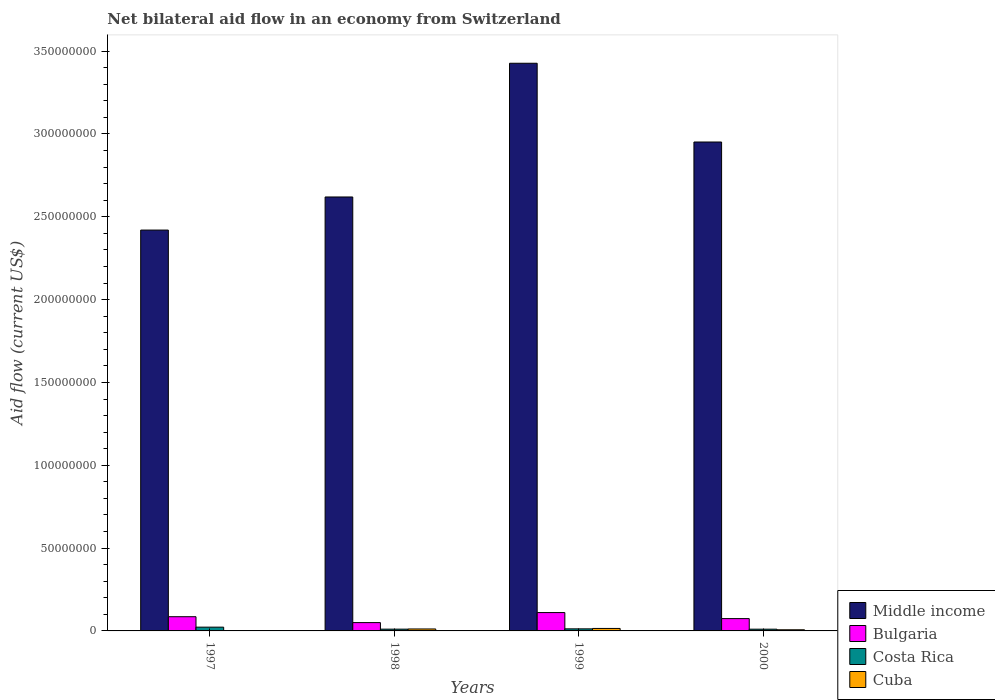Are the number of bars on each tick of the X-axis equal?
Give a very brief answer. Yes. How many bars are there on the 3rd tick from the right?
Offer a very short reply. 4. What is the label of the 1st group of bars from the left?
Your answer should be compact. 1997. What is the net bilateral aid flow in Cuba in 2000?
Keep it short and to the point. 6.90e+05. Across all years, what is the maximum net bilateral aid flow in Bulgaria?
Give a very brief answer. 1.11e+07. Across all years, what is the minimum net bilateral aid flow in Middle income?
Give a very brief answer. 2.42e+08. In which year was the net bilateral aid flow in Middle income maximum?
Offer a very short reply. 1999. What is the total net bilateral aid flow in Middle income in the graph?
Your answer should be compact. 1.14e+09. What is the difference between the net bilateral aid flow in Middle income in 1997 and that in 2000?
Provide a succinct answer. -5.32e+07. What is the difference between the net bilateral aid flow in Cuba in 1997 and the net bilateral aid flow in Bulgaria in 1999?
Your answer should be very brief. -1.09e+07. What is the average net bilateral aid flow in Bulgaria per year?
Provide a succinct answer. 8.03e+06. In the year 2000, what is the difference between the net bilateral aid flow in Costa Rica and net bilateral aid flow in Bulgaria?
Keep it short and to the point. -6.39e+06. What is the ratio of the net bilateral aid flow in Bulgaria in 1998 to that in 1999?
Your answer should be compact. 0.45. Is the net bilateral aid flow in Cuba in 1998 less than that in 2000?
Make the answer very short. No. What is the difference between the highest and the lowest net bilateral aid flow in Bulgaria?
Provide a short and direct response. 6.06e+06. In how many years, is the net bilateral aid flow in Middle income greater than the average net bilateral aid flow in Middle income taken over all years?
Your response must be concise. 2. What does the 4th bar from the right in 1999 represents?
Give a very brief answer. Middle income. Are all the bars in the graph horizontal?
Make the answer very short. No. How many years are there in the graph?
Give a very brief answer. 4. Does the graph contain any zero values?
Ensure brevity in your answer.  No. Does the graph contain grids?
Provide a short and direct response. No. Where does the legend appear in the graph?
Your answer should be compact. Bottom right. What is the title of the graph?
Provide a succinct answer. Net bilateral aid flow in an economy from Switzerland. What is the label or title of the X-axis?
Your answer should be very brief. Years. What is the Aid flow (current US$) of Middle income in 1997?
Ensure brevity in your answer.  2.42e+08. What is the Aid flow (current US$) in Bulgaria in 1997?
Keep it short and to the point. 8.58e+06. What is the Aid flow (current US$) in Costa Rica in 1997?
Ensure brevity in your answer.  2.28e+06. What is the Aid flow (current US$) of Middle income in 1998?
Provide a short and direct response. 2.62e+08. What is the Aid flow (current US$) of Bulgaria in 1998?
Provide a short and direct response. 5.02e+06. What is the Aid flow (current US$) of Costa Rica in 1998?
Your answer should be very brief. 1.07e+06. What is the Aid flow (current US$) of Cuba in 1998?
Offer a very short reply. 1.18e+06. What is the Aid flow (current US$) of Middle income in 1999?
Offer a very short reply. 3.43e+08. What is the Aid flow (current US$) in Bulgaria in 1999?
Offer a very short reply. 1.11e+07. What is the Aid flow (current US$) in Costa Rica in 1999?
Your answer should be very brief. 1.25e+06. What is the Aid flow (current US$) in Cuba in 1999?
Make the answer very short. 1.49e+06. What is the Aid flow (current US$) of Middle income in 2000?
Offer a terse response. 2.95e+08. What is the Aid flow (current US$) in Bulgaria in 2000?
Your answer should be compact. 7.44e+06. What is the Aid flow (current US$) in Costa Rica in 2000?
Your answer should be very brief. 1.05e+06. What is the Aid flow (current US$) in Cuba in 2000?
Offer a very short reply. 6.90e+05. Across all years, what is the maximum Aid flow (current US$) in Middle income?
Offer a terse response. 3.43e+08. Across all years, what is the maximum Aid flow (current US$) in Bulgaria?
Offer a very short reply. 1.11e+07. Across all years, what is the maximum Aid flow (current US$) of Costa Rica?
Keep it short and to the point. 2.28e+06. Across all years, what is the maximum Aid flow (current US$) of Cuba?
Offer a terse response. 1.49e+06. Across all years, what is the minimum Aid flow (current US$) in Middle income?
Provide a short and direct response. 2.42e+08. Across all years, what is the minimum Aid flow (current US$) in Bulgaria?
Provide a succinct answer. 5.02e+06. Across all years, what is the minimum Aid flow (current US$) of Costa Rica?
Offer a very short reply. 1.05e+06. What is the total Aid flow (current US$) of Middle income in the graph?
Provide a short and direct response. 1.14e+09. What is the total Aid flow (current US$) of Bulgaria in the graph?
Provide a succinct answer. 3.21e+07. What is the total Aid flow (current US$) in Costa Rica in the graph?
Your answer should be compact. 5.65e+06. What is the total Aid flow (current US$) of Cuba in the graph?
Ensure brevity in your answer.  3.52e+06. What is the difference between the Aid flow (current US$) in Middle income in 1997 and that in 1998?
Your answer should be compact. -2.00e+07. What is the difference between the Aid flow (current US$) of Bulgaria in 1997 and that in 1998?
Your answer should be compact. 3.56e+06. What is the difference between the Aid flow (current US$) of Costa Rica in 1997 and that in 1998?
Make the answer very short. 1.21e+06. What is the difference between the Aid flow (current US$) in Cuba in 1997 and that in 1998?
Provide a succinct answer. -1.02e+06. What is the difference between the Aid flow (current US$) in Middle income in 1997 and that in 1999?
Your response must be concise. -1.01e+08. What is the difference between the Aid flow (current US$) of Bulgaria in 1997 and that in 1999?
Provide a succinct answer. -2.50e+06. What is the difference between the Aid flow (current US$) in Costa Rica in 1997 and that in 1999?
Ensure brevity in your answer.  1.03e+06. What is the difference between the Aid flow (current US$) in Cuba in 1997 and that in 1999?
Keep it short and to the point. -1.33e+06. What is the difference between the Aid flow (current US$) of Middle income in 1997 and that in 2000?
Make the answer very short. -5.32e+07. What is the difference between the Aid flow (current US$) of Bulgaria in 1997 and that in 2000?
Make the answer very short. 1.14e+06. What is the difference between the Aid flow (current US$) of Costa Rica in 1997 and that in 2000?
Your answer should be compact. 1.23e+06. What is the difference between the Aid flow (current US$) in Cuba in 1997 and that in 2000?
Keep it short and to the point. -5.30e+05. What is the difference between the Aid flow (current US$) of Middle income in 1998 and that in 1999?
Ensure brevity in your answer.  -8.07e+07. What is the difference between the Aid flow (current US$) of Bulgaria in 1998 and that in 1999?
Offer a terse response. -6.06e+06. What is the difference between the Aid flow (current US$) in Costa Rica in 1998 and that in 1999?
Give a very brief answer. -1.80e+05. What is the difference between the Aid flow (current US$) in Cuba in 1998 and that in 1999?
Offer a very short reply. -3.10e+05. What is the difference between the Aid flow (current US$) in Middle income in 1998 and that in 2000?
Ensure brevity in your answer.  -3.32e+07. What is the difference between the Aid flow (current US$) of Bulgaria in 1998 and that in 2000?
Provide a succinct answer. -2.42e+06. What is the difference between the Aid flow (current US$) in Costa Rica in 1998 and that in 2000?
Offer a terse response. 2.00e+04. What is the difference between the Aid flow (current US$) of Cuba in 1998 and that in 2000?
Your response must be concise. 4.90e+05. What is the difference between the Aid flow (current US$) of Middle income in 1999 and that in 2000?
Offer a terse response. 4.75e+07. What is the difference between the Aid flow (current US$) of Bulgaria in 1999 and that in 2000?
Your answer should be compact. 3.64e+06. What is the difference between the Aid flow (current US$) of Cuba in 1999 and that in 2000?
Ensure brevity in your answer.  8.00e+05. What is the difference between the Aid flow (current US$) of Middle income in 1997 and the Aid flow (current US$) of Bulgaria in 1998?
Make the answer very short. 2.37e+08. What is the difference between the Aid flow (current US$) of Middle income in 1997 and the Aid flow (current US$) of Costa Rica in 1998?
Offer a very short reply. 2.41e+08. What is the difference between the Aid flow (current US$) of Middle income in 1997 and the Aid flow (current US$) of Cuba in 1998?
Offer a very short reply. 2.41e+08. What is the difference between the Aid flow (current US$) in Bulgaria in 1997 and the Aid flow (current US$) in Costa Rica in 1998?
Keep it short and to the point. 7.51e+06. What is the difference between the Aid flow (current US$) in Bulgaria in 1997 and the Aid flow (current US$) in Cuba in 1998?
Offer a terse response. 7.40e+06. What is the difference between the Aid flow (current US$) in Costa Rica in 1997 and the Aid flow (current US$) in Cuba in 1998?
Give a very brief answer. 1.10e+06. What is the difference between the Aid flow (current US$) of Middle income in 1997 and the Aid flow (current US$) of Bulgaria in 1999?
Your answer should be compact. 2.31e+08. What is the difference between the Aid flow (current US$) of Middle income in 1997 and the Aid flow (current US$) of Costa Rica in 1999?
Your answer should be compact. 2.41e+08. What is the difference between the Aid flow (current US$) in Middle income in 1997 and the Aid flow (current US$) in Cuba in 1999?
Your response must be concise. 2.40e+08. What is the difference between the Aid flow (current US$) of Bulgaria in 1997 and the Aid flow (current US$) of Costa Rica in 1999?
Ensure brevity in your answer.  7.33e+06. What is the difference between the Aid flow (current US$) in Bulgaria in 1997 and the Aid flow (current US$) in Cuba in 1999?
Offer a terse response. 7.09e+06. What is the difference between the Aid flow (current US$) in Costa Rica in 1997 and the Aid flow (current US$) in Cuba in 1999?
Make the answer very short. 7.90e+05. What is the difference between the Aid flow (current US$) of Middle income in 1997 and the Aid flow (current US$) of Bulgaria in 2000?
Make the answer very short. 2.35e+08. What is the difference between the Aid flow (current US$) of Middle income in 1997 and the Aid flow (current US$) of Costa Rica in 2000?
Your answer should be very brief. 2.41e+08. What is the difference between the Aid flow (current US$) in Middle income in 1997 and the Aid flow (current US$) in Cuba in 2000?
Make the answer very short. 2.41e+08. What is the difference between the Aid flow (current US$) in Bulgaria in 1997 and the Aid flow (current US$) in Costa Rica in 2000?
Your response must be concise. 7.53e+06. What is the difference between the Aid flow (current US$) of Bulgaria in 1997 and the Aid flow (current US$) of Cuba in 2000?
Provide a succinct answer. 7.89e+06. What is the difference between the Aid flow (current US$) of Costa Rica in 1997 and the Aid flow (current US$) of Cuba in 2000?
Provide a short and direct response. 1.59e+06. What is the difference between the Aid flow (current US$) in Middle income in 1998 and the Aid flow (current US$) in Bulgaria in 1999?
Provide a succinct answer. 2.51e+08. What is the difference between the Aid flow (current US$) of Middle income in 1998 and the Aid flow (current US$) of Costa Rica in 1999?
Provide a succinct answer. 2.61e+08. What is the difference between the Aid flow (current US$) in Middle income in 1998 and the Aid flow (current US$) in Cuba in 1999?
Ensure brevity in your answer.  2.60e+08. What is the difference between the Aid flow (current US$) of Bulgaria in 1998 and the Aid flow (current US$) of Costa Rica in 1999?
Make the answer very short. 3.77e+06. What is the difference between the Aid flow (current US$) in Bulgaria in 1998 and the Aid flow (current US$) in Cuba in 1999?
Offer a terse response. 3.53e+06. What is the difference between the Aid flow (current US$) of Costa Rica in 1998 and the Aid flow (current US$) of Cuba in 1999?
Ensure brevity in your answer.  -4.20e+05. What is the difference between the Aid flow (current US$) of Middle income in 1998 and the Aid flow (current US$) of Bulgaria in 2000?
Give a very brief answer. 2.55e+08. What is the difference between the Aid flow (current US$) in Middle income in 1998 and the Aid flow (current US$) in Costa Rica in 2000?
Make the answer very short. 2.61e+08. What is the difference between the Aid flow (current US$) in Middle income in 1998 and the Aid flow (current US$) in Cuba in 2000?
Provide a short and direct response. 2.61e+08. What is the difference between the Aid flow (current US$) of Bulgaria in 1998 and the Aid flow (current US$) of Costa Rica in 2000?
Your response must be concise. 3.97e+06. What is the difference between the Aid flow (current US$) of Bulgaria in 1998 and the Aid flow (current US$) of Cuba in 2000?
Keep it short and to the point. 4.33e+06. What is the difference between the Aid flow (current US$) of Costa Rica in 1998 and the Aid flow (current US$) of Cuba in 2000?
Your answer should be very brief. 3.80e+05. What is the difference between the Aid flow (current US$) of Middle income in 1999 and the Aid flow (current US$) of Bulgaria in 2000?
Make the answer very short. 3.35e+08. What is the difference between the Aid flow (current US$) in Middle income in 1999 and the Aid flow (current US$) in Costa Rica in 2000?
Provide a short and direct response. 3.42e+08. What is the difference between the Aid flow (current US$) in Middle income in 1999 and the Aid flow (current US$) in Cuba in 2000?
Provide a short and direct response. 3.42e+08. What is the difference between the Aid flow (current US$) in Bulgaria in 1999 and the Aid flow (current US$) in Costa Rica in 2000?
Your answer should be compact. 1.00e+07. What is the difference between the Aid flow (current US$) of Bulgaria in 1999 and the Aid flow (current US$) of Cuba in 2000?
Provide a succinct answer. 1.04e+07. What is the difference between the Aid flow (current US$) in Costa Rica in 1999 and the Aid flow (current US$) in Cuba in 2000?
Offer a terse response. 5.60e+05. What is the average Aid flow (current US$) of Middle income per year?
Provide a succinct answer. 2.85e+08. What is the average Aid flow (current US$) of Bulgaria per year?
Offer a very short reply. 8.03e+06. What is the average Aid flow (current US$) of Costa Rica per year?
Provide a succinct answer. 1.41e+06. What is the average Aid flow (current US$) in Cuba per year?
Your answer should be compact. 8.80e+05. In the year 1997, what is the difference between the Aid flow (current US$) in Middle income and Aid flow (current US$) in Bulgaria?
Your answer should be compact. 2.33e+08. In the year 1997, what is the difference between the Aid flow (current US$) in Middle income and Aid flow (current US$) in Costa Rica?
Give a very brief answer. 2.40e+08. In the year 1997, what is the difference between the Aid flow (current US$) of Middle income and Aid flow (current US$) of Cuba?
Your answer should be very brief. 2.42e+08. In the year 1997, what is the difference between the Aid flow (current US$) in Bulgaria and Aid flow (current US$) in Costa Rica?
Offer a very short reply. 6.30e+06. In the year 1997, what is the difference between the Aid flow (current US$) of Bulgaria and Aid flow (current US$) of Cuba?
Your answer should be compact. 8.42e+06. In the year 1997, what is the difference between the Aid flow (current US$) in Costa Rica and Aid flow (current US$) in Cuba?
Your answer should be compact. 2.12e+06. In the year 1998, what is the difference between the Aid flow (current US$) in Middle income and Aid flow (current US$) in Bulgaria?
Provide a succinct answer. 2.57e+08. In the year 1998, what is the difference between the Aid flow (current US$) in Middle income and Aid flow (current US$) in Costa Rica?
Provide a short and direct response. 2.61e+08. In the year 1998, what is the difference between the Aid flow (current US$) in Middle income and Aid flow (current US$) in Cuba?
Make the answer very short. 2.61e+08. In the year 1998, what is the difference between the Aid flow (current US$) of Bulgaria and Aid flow (current US$) of Costa Rica?
Your response must be concise. 3.95e+06. In the year 1998, what is the difference between the Aid flow (current US$) of Bulgaria and Aid flow (current US$) of Cuba?
Your response must be concise. 3.84e+06. In the year 1999, what is the difference between the Aid flow (current US$) in Middle income and Aid flow (current US$) in Bulgaria?
Provide a succinct answer. 3.32e+08. In the year 1999, what is the difference between the Aid flow (current US$) of Middle income and Aid flow (current US$) of Costa Rica?
Provide a succinct answer. 3.41e+08. In the year 1999, what is the difference between the Aid flow (current US$) of Middle income and Aid flow (current US$) of Cuba?
Keep it short and to the point. 3.41e+08. In the year 1999, what is the difference between the Aid flow (current US$) in Bulgaria and Aid flow (current US$) in Costa Rica?
Offer a very short reply. 9.83e+06. In the year 1999, what is the difference between the Aid flow (current US$) in Bulgaria and Aid flow (current US$) in Cuba?
Keep it short and to the point. 9.59e+06. In the year 2000, what is the difference between the Aid flow (current US$) in Middle income and Aid flow (current US$) in Bulgaria?
Ensure brevity in your answer.  2.88e+08. In the year 2000, what is the difference between the Aid flow (current US$) of Middle income and Aid flow (current US$) of Costa Rica?
Your response must be concise. 2.94e+08. In the year 2000, what is the difference between the Aid flow (current US$) in Middle income and Aid flow (current US$) in Cuba?
Keep it short and to the point. 2.94e+08. In the year 2000, what is the difference between the Aid flow (current US$) in Bulgaria and Aid flow (current US$) in Costa Rica?
Your answer should be very brief. 6.39e+06. In the year 2000, what is the difference between the Aid flow (current US$) in Bulgaria and Aid flow (current US$) in Cuba?
Give a very brief answer. 6.75e+06. What is the ratio of the Aid flow (current US$) in Middle income in 1997 to that in 1998?
Ensure brevity in your answer.  0.92. What is the ratio of the Aid flow (current US$) in Bulgaria in 1997 to that in 1998?
Give a very brief answer. 1.71. What is the ratio of the Aid flow (current US$) of Costa Rica in 1997 to that in 1998?
Your response must be concise. 2.13. What is the ratio of the Aid flow (current US$) of Cuba in 1997 to that in 1998?
Ensure brevity in your answer.  0.14. What is the ratio of the Aid flow (current US$) of Middle income in 1997 to that in 1999?
Provide a short and direct response. 0.71. What is the ratio of the Aid flow (current US$) in Bulgaria in 1997 to that in 1999?
Provide a short and direct response. 0.77. What is the ratio of the Aid flow (current US$) in Costa Rica in 1997 to that in 1999?
Provide a succinct answer. 1.82. What is the ratio of the Aid flow (current US$) of Cuba in 1997 to that in 1999?
Keep it short and to the point. 0.11. What is the ratio of the Aid flow (current US$) of Middle income in 1997 to that in 2000?
Provide a succinct answer. 0.82. What is the ratio of the Aid flow (current US$) in Bulgaria in 1997 to that in 2000?
Your answer should be very brief. 1.15. What is the ratio of the Aid flow (current US$) of Costa Rica in 1997 to that in 2000?
Give a very brief answer. 2.17. What is the ratio of the Aid flow (current US$) in Cuba in 1997 to that in 2000?
Provide a succinct answer. 0.23. What is the ratio of the Aid flow (current US$) of Middle income in 1998 to that in 1999?
Offer a terse response. 0.76. What is the ratio of the Aid flow (current US$) in Bulgaria in 1998 to that in 1999?
Keep it short and to the point. 0.45. What is the ratio of the Aid flow (current US$) in Costa Rica in 1998 to that in 1999?
Ensure brevity in your answer.  0.86. What is the ratio of the Aid flow (current US$) in Cuba in 1998 to that in 1999?
Provide a succinct answer. 0.79. What is the ratio of the Aid flow (current US$) in Middle income in 1998 to that in 2000?
Give a very brief answer. 0.89. What is the ratio of the Aid flow (current US$) in Bulgaria in 1998 to that in 2000?
Your answer should be compact. 0.67. What is the ratio of the Aid flow (current US$) in Cuba in 1998 to that in 2000?
Ensure brevity in your answer.  1.71. What is the ratio of the Aid flow (current US$) of Middle income in 1999 to that in 2000?
Ensure brevity in your answer.  1.16. What is the ratio of the Aid flow (current US$) in Bulgaria in 1999 to that in 2000?
Offer a terse response. 1.49. What is the ratio of the Aid flow (current US$) of Costa Rica in 1999 to that in 2000?
Make the answer very short. 1.19. What is the ratio of the Aid flow (current US$) in Cuba in 1999 to that in 2000?
Your response must be concise. 2.16. What is the difference between the highest and the second highest Aid flow (current US$) of Middle income?
Give a very brief answer. 4.75e+07. What is the difference between the highest and the second highest Aid flow (current US$) in Bulgaria?
Your response must be concise. 2.50e+06. What is the difference between the highest and the second highest Aid flow (current US$) in Costa Rica?
Provide a succinct answer. 1.03e+06. What is the difference between the highest and the lowest Aid flow (current US$) of Middle income?
Your answer should be compact. 1.01e+08. What is the difference between the highest and the lowest Aid flow (current US$) of Bulgaria?
Your answer should be compact. 6.06e+06. What is the difference between the highest and the lowest Aid flow (current US$) in Costa Rica?
Give a very brief answer. 1.23e+06. What is the difference between the highest and the lowest Aid flow (current US$) in Cuba?
Your response must be concise. 1.33e+06. 